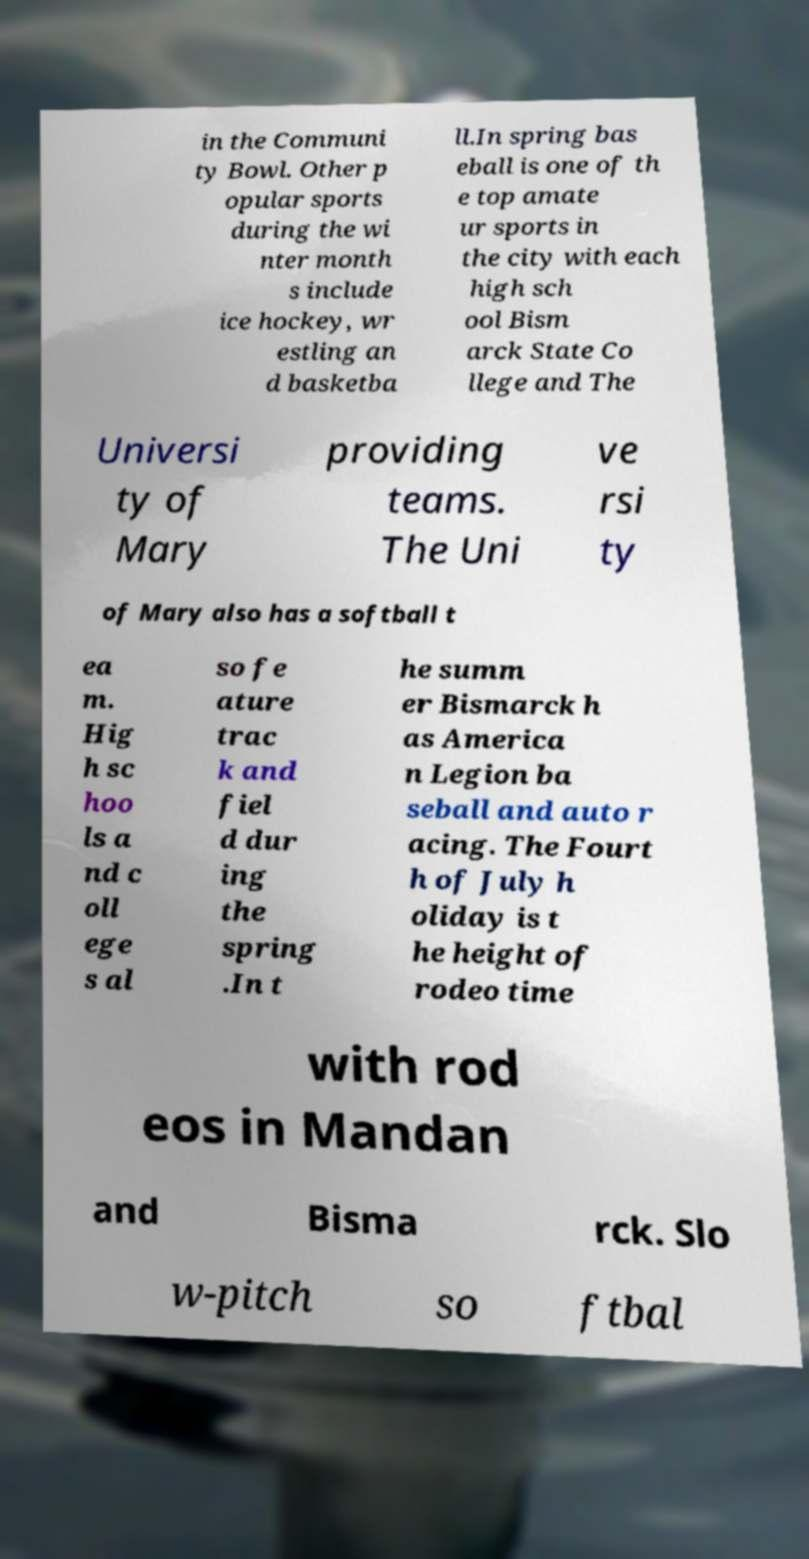For documentation purposes, I need the text within this image transcribed. Could you provide that? in the Communi ty Bowl. Other p opular sports during the wi nter month s include ice hockey, wr estling an d basketba ll.In spring bas eball is one of th e top amate ur sports in the city with each high sch ool Bism arck State Co llege and The Universi ty of Mary providing teams. The Uni ve rsi ty of Mary also has a softball t ea m. Hig h sc hoo ls a nd c oll ege s al so fe ature trac k and fiel d dur ing the spring .In t he summ er Bismarck h as America n Legion ba seball and auto r acing. The Fourt h of July h oliday is t he height of rodeo time with rod eos in Mandan and Bisma rck. Slo w-pitch so ftbal 